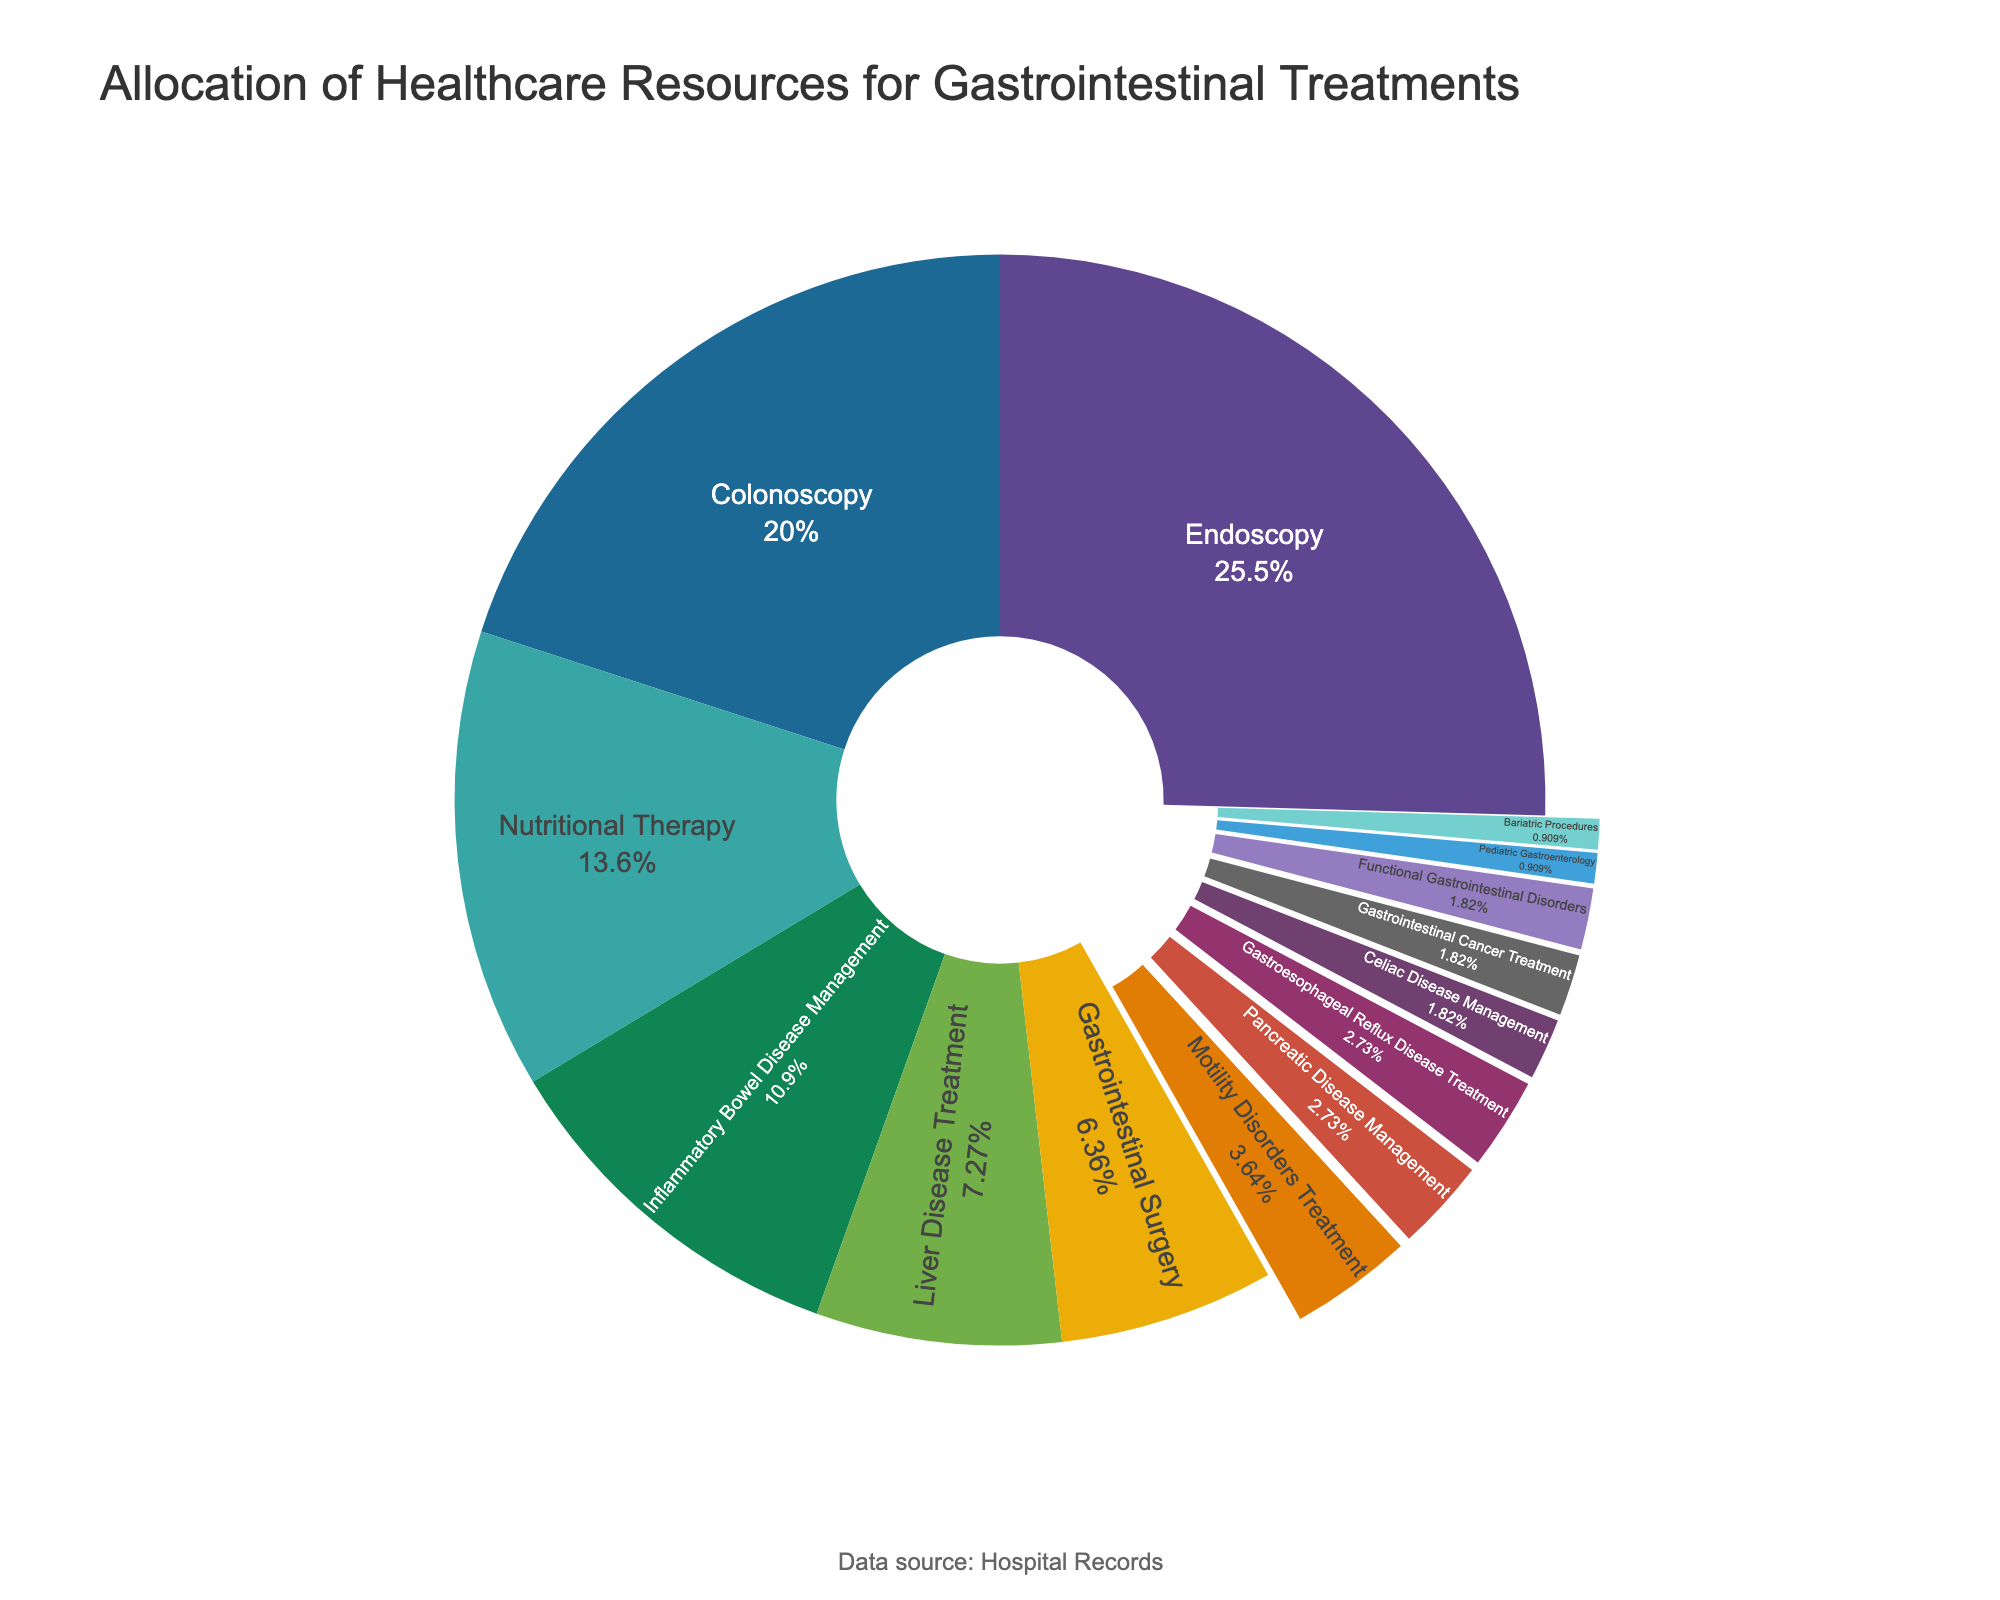What is the percentage of resources allocated to Nutritional Therapy and Liver Disease Treatment combined? Add the percentages for Nutritional Therapy (15%) and Liver Disease Treatment (8%) to get the total allocation for both treatments: 15% + 8% = 23%
Answer: 23% How does the allocation for Gastroesophageal Reflux Disease Treatment compare to Pancreatic Disease Management? The percentage for Gastroesophageal Reflux Disease Treatment is 3%, and for Pancreatic Disease Management, it's also 3%. Since both percentages are the same, the resources allocated are equal.
Answer: Equal (3%) What fraction of the total resources is allocated to treatments associated with metabolic or functional issues (Nutritional Therapy, Functional Gastrointestinal Disorders, and Bariatric Procedures)? Adding the percentages for Nutritional Therapy (15%), Functional Gastrointestinal Disorders (2%), and Bariatric Procedures (1%): 15% + 2% + 1% = 18%. Converting this to a fraction of the total, it’s 18/100 or 9/50.
Answer: 9/50 Which treatment category has the highest allocation of resources and what percentage is it? By inspecting the pie chart, the segment with the largest area represents Endoscopy. The percentage allocated to Endoscopy is 28%, which is the highest among all treatments.
Answer: Endoscopy (28%) What is the difference in resource allocation between Colonoscopy and Gastrointestinal Surgery? The percentage for Colonoscopy is 22%, and for Gastrointestinal Surgery, it is 7%. The difference between them is 22% - 7% = 15%.
Answer: 15% Are more resources allocated to Inflammatory Bowel Disease Management or Liver Disease Treatment? By inspecting their respective slices on the pie chart, Inflammatory Bowel Disease Management has 12%, whereas Liver Disease Treatment has 8%. Therefore, more resources are allocated to Inflammatory Bowel Disease Management.
Answer: Inflammatory Bowel Disease Management What is the visual cue used to emphasize smaller treatment allocations on the pie chart? Smaller slices in the pie chart are visually pulled out slightly from the main circle to highlight them.
Answer: Pulled out slices How do the resources allocated to Pediatric Gastroenterology compare to the resources allocated to Bariatric Procedures? Both Pediatric Gastroenterology and Bariatric Procedures are allocated 1% of the resources. They are equal.
Answer: Equal (1%) What is the combined allocation of resources for treatments each receiving exactly 2%? Treatments with exactly 2% are Celiac Disease Management, Gastroesophageal Reflux Disease Treatment, Gastrointestinal Cancer Treatment, and Functional Gastrointestinal Disorders. Adding them up: 2% + 2% + 2% + 2% = 8%.
Answer: 8% How much greater is the allocation for Endoscopy than for Motility Disorders Treatment? The percentage for Endoscopy is 28% while for Motility Disorders Treatment it is 4%. The difference is: 28% - 4% = 24%.
Answer: 24% 